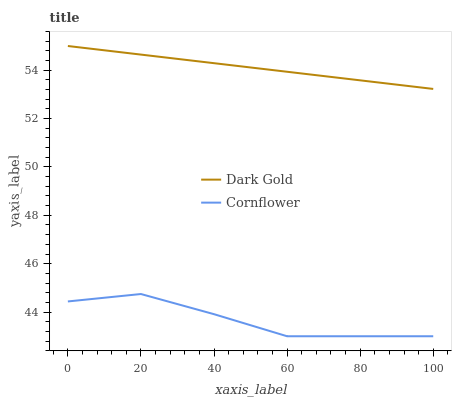Does Cornflower have the minimum area under the curve?
Answer yes or no. Yes. Does Dark Gold have the maximum area under the curve?
Answer yes or no. Yes. Does Dark Gold have the minimum area under the curve?
Answer yes or no. No. Is Dark Gold the smoothest?
Answer yes or no. Yes. Is Cornflower the roughest?
Answer yes or no. Yes. Is Dark Gold the roughest?
Answer yes or no. No. Does Cornflower have the lowest value?
Answer yes or no. Yes. Does Dark Gold have the lowest value?
Answer yes or no. No. Does Dark Gold have the highest value?
Answer yes or no. Yes. Is Cornflower less than Dark Gold?
Answer yes or no. Yes. Is Dark Gold greater than Cornflower?
Answer yes or no. Yes. Does Cornflower intersect Dark Gold?
Answer yes or no. No. 